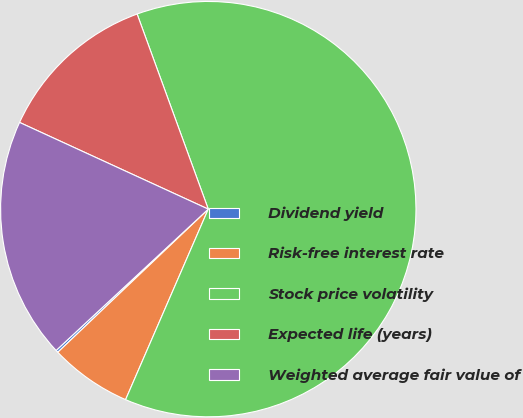Convert chart. <chart><loc_0><loc_0><loc_500><loc_500><pie_chart><fcel>Dividend yield<fcel>Risk-free interest rate<fcel>Stock price volatility<fcel>Expected life (years)<fcel>Weighted average fair value of<nl><fcel>0.19%<fcel>6.38%<fcel>62.09%<fcel>12.58%<fcel>18.77%<nl></chart> 